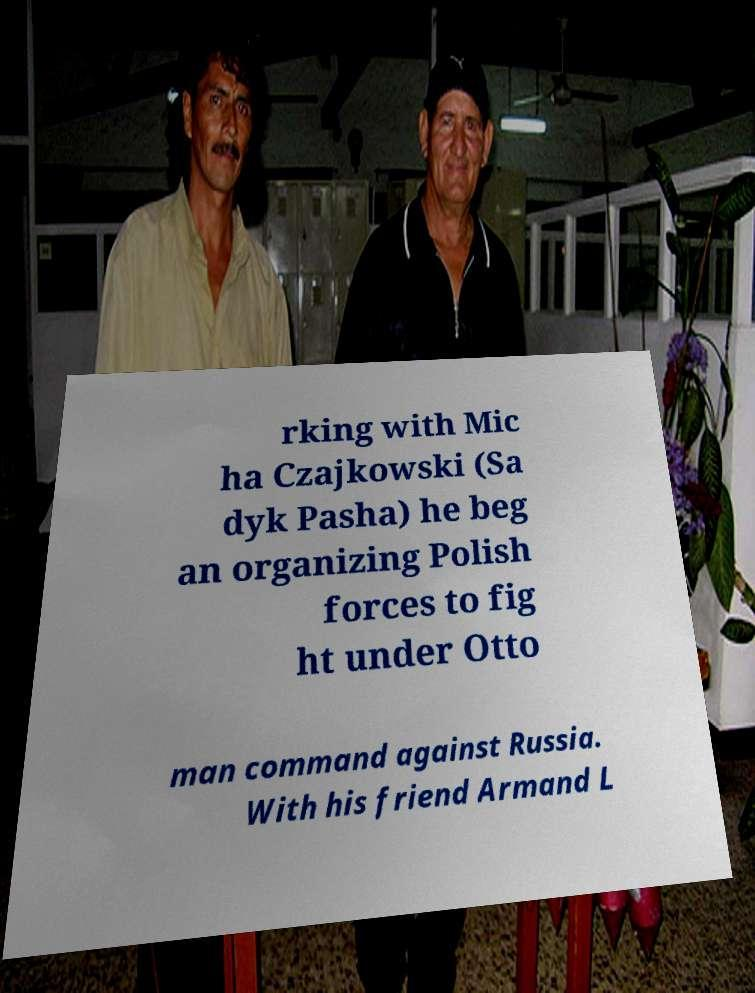What messages or text are displayed in this image? I need them in a readable, typed format. rking with Mic ha Czajkowski (Sa dyk Pasha) he beg an organizing Polish forces to fig ht under Otto man command against Russia. With his friend Armand L 